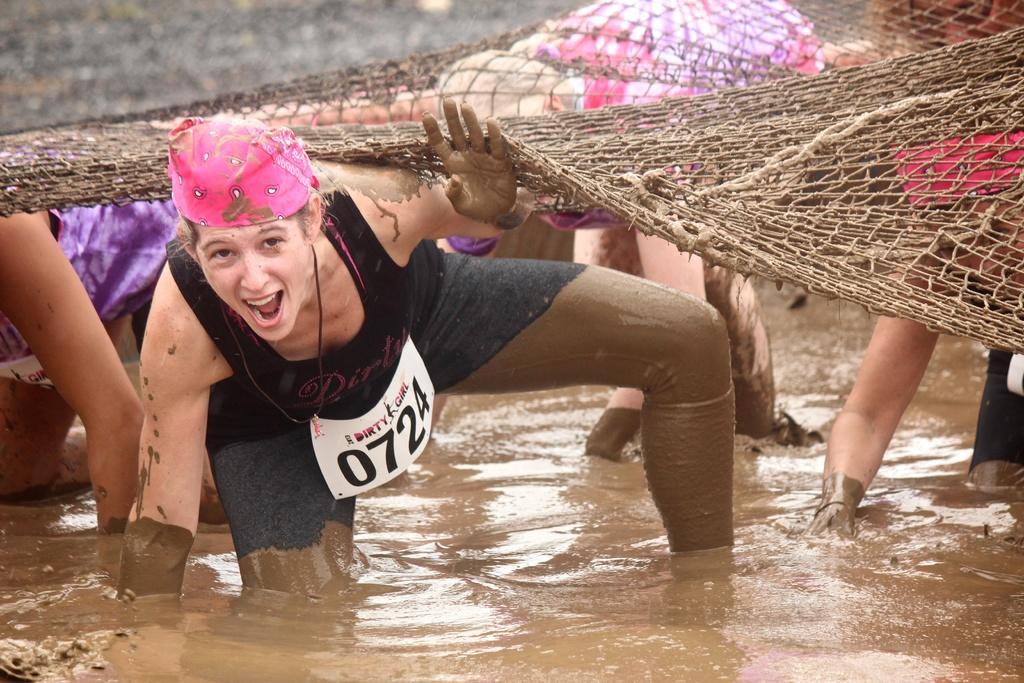How many people are in the image? There are persons in the image, but the exact number is not specified. What is the environment like in the image? The persons are in mud water. What is above the persons in the image? There is a net above the persons. What type of goose can be seen swimming in the mud water in the image? There is no goose present in the image; it only features persons in mud water with a net above them. 